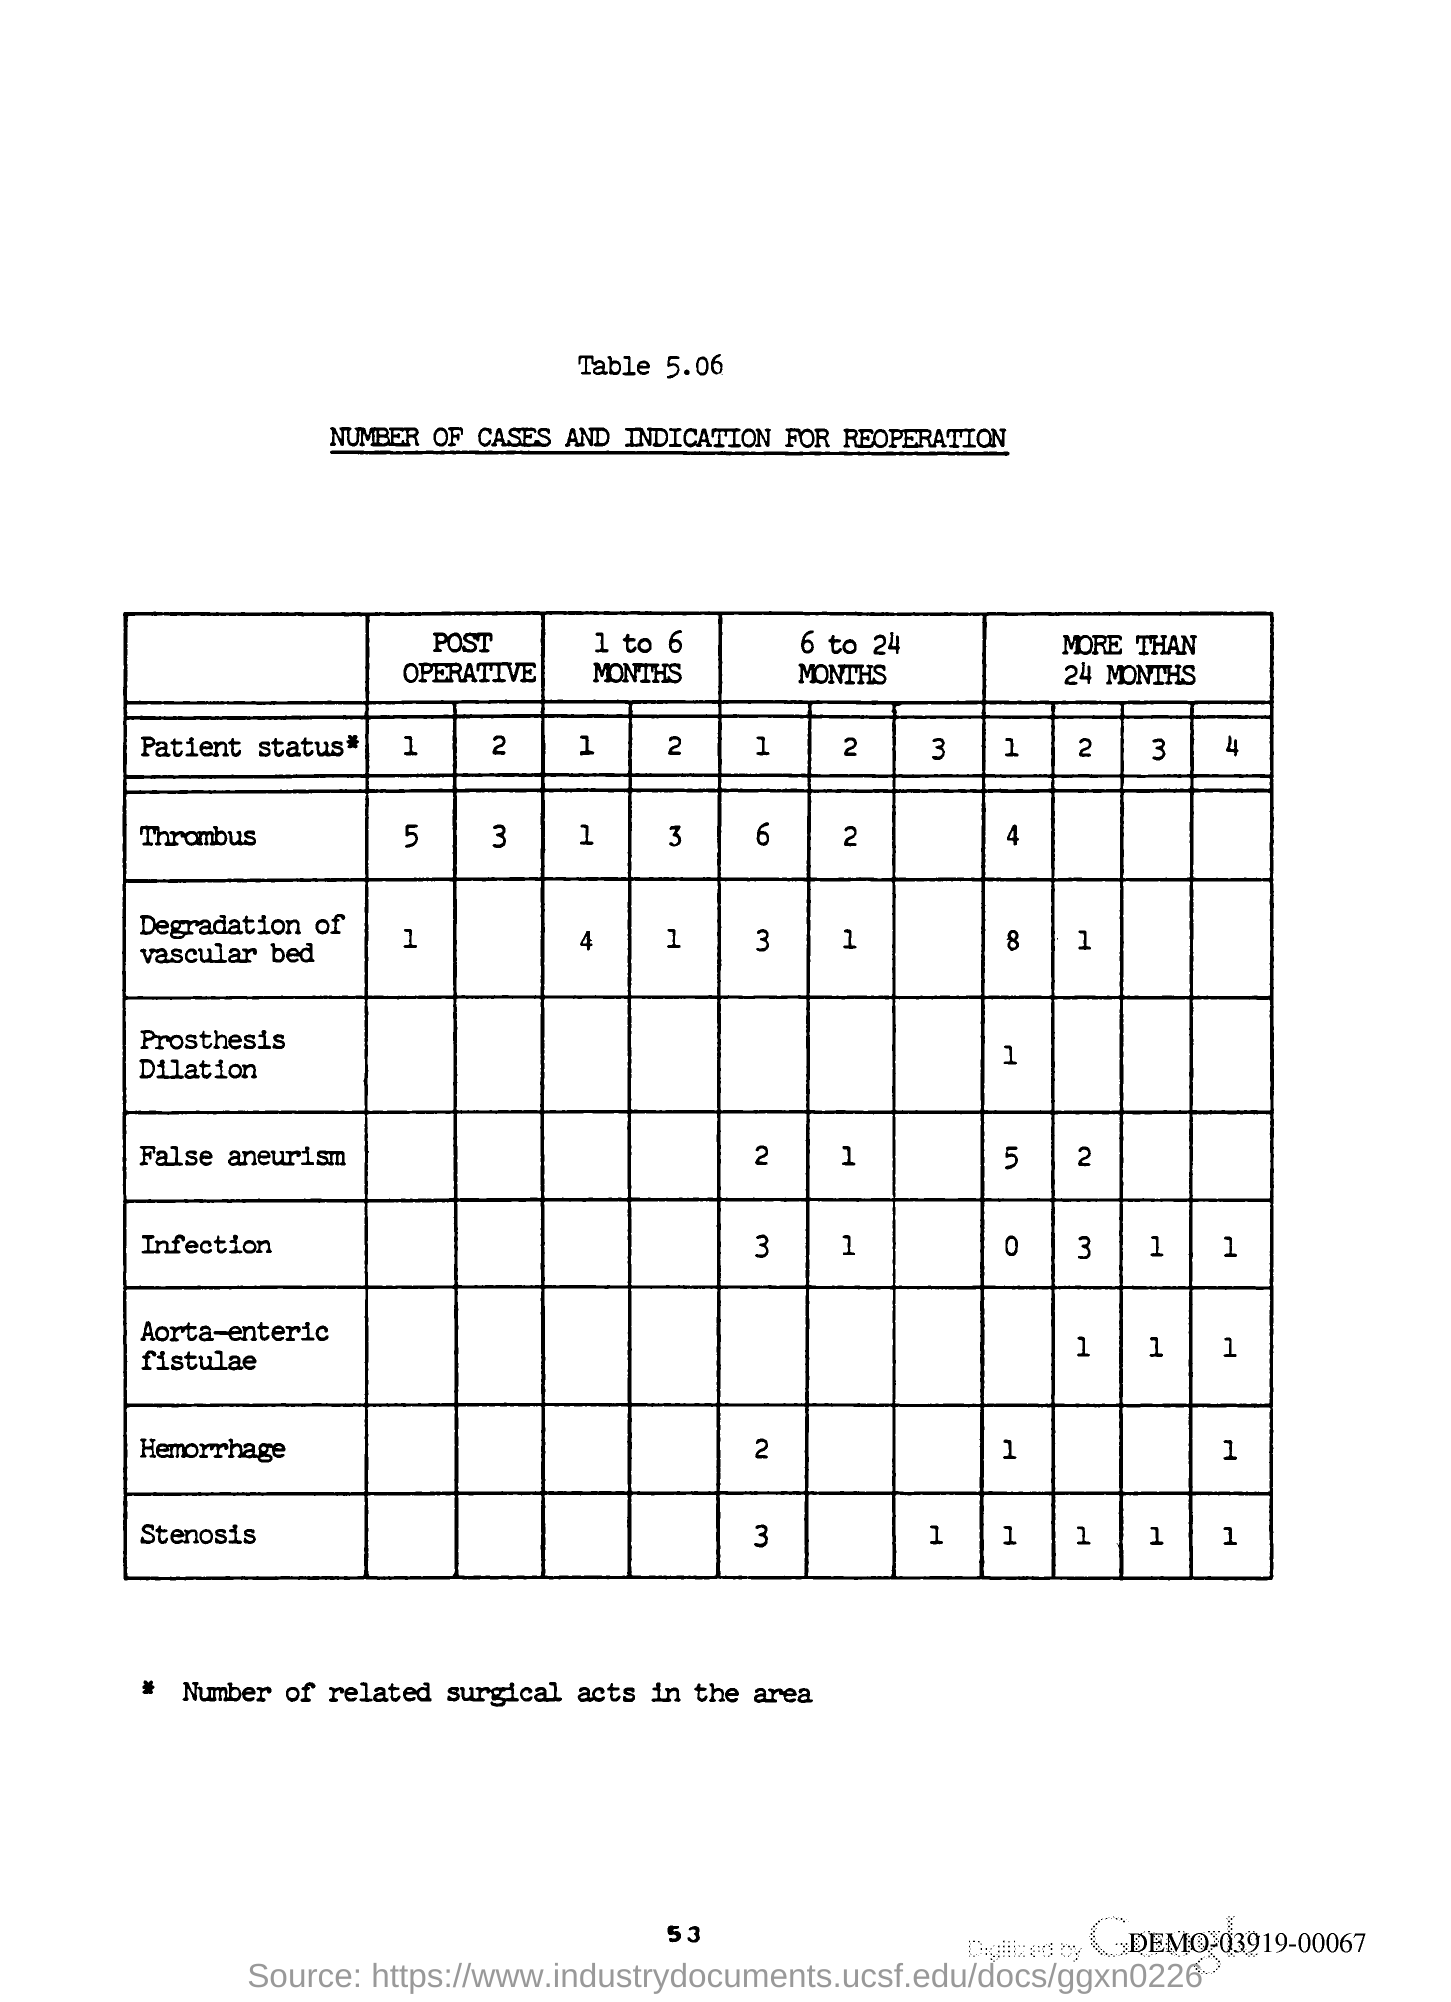Outline some significant characteristics in this image. The title of table 5.06 is 'Number of Cases and Indication for Reoperation.' The page number is 53. 